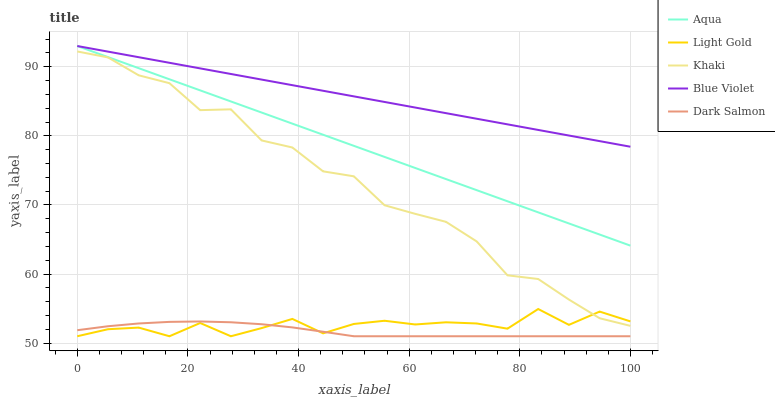Does Dark Salmon have the minimum area under the curve?
Answer yes or no. Yes. Does Blue Violet have the maximum area under the curve?
Answer yes or no. Yes. Does Khaki have the minimum area under the curve?
Answer yes or no. No. Does Khaki have the maximum area under the curve?
Answer yes or no. No. Is Blue Violet the smoothest?
Answer yes or no. Yes. Is Khaki the roughest?
Answer yes or no. Yes. Is Aqua the smoothest?
Answer yes or no. No. Is Aqua the roughest?
Answer yes or no. No. Does Light Gold have the lowest value?
Answer yes or no. Yes. Does Khaki have the lowest value?
Answer yes or no. No. Does Blue Violet have the highest value?
Answer yes or no. Yes. Does Khaki have the highest value?
Answer yes or no. No. Is Light Gold less than Blue Violet?
Answer yes or no. Yes. Is Aqua greater than Khaki?
Answer yes or no. Yes. Does Light Gold intersect Dark Salmon?
Answer yes or no. Yes. Is Light Gold less than Dark Salmon?
Answer yes or no. No. Is Light Gold greater than Dark Salmon?
Answer yes or no. No. Does Light Gold intersect Blue Violet?
Answer yes or no. No. 